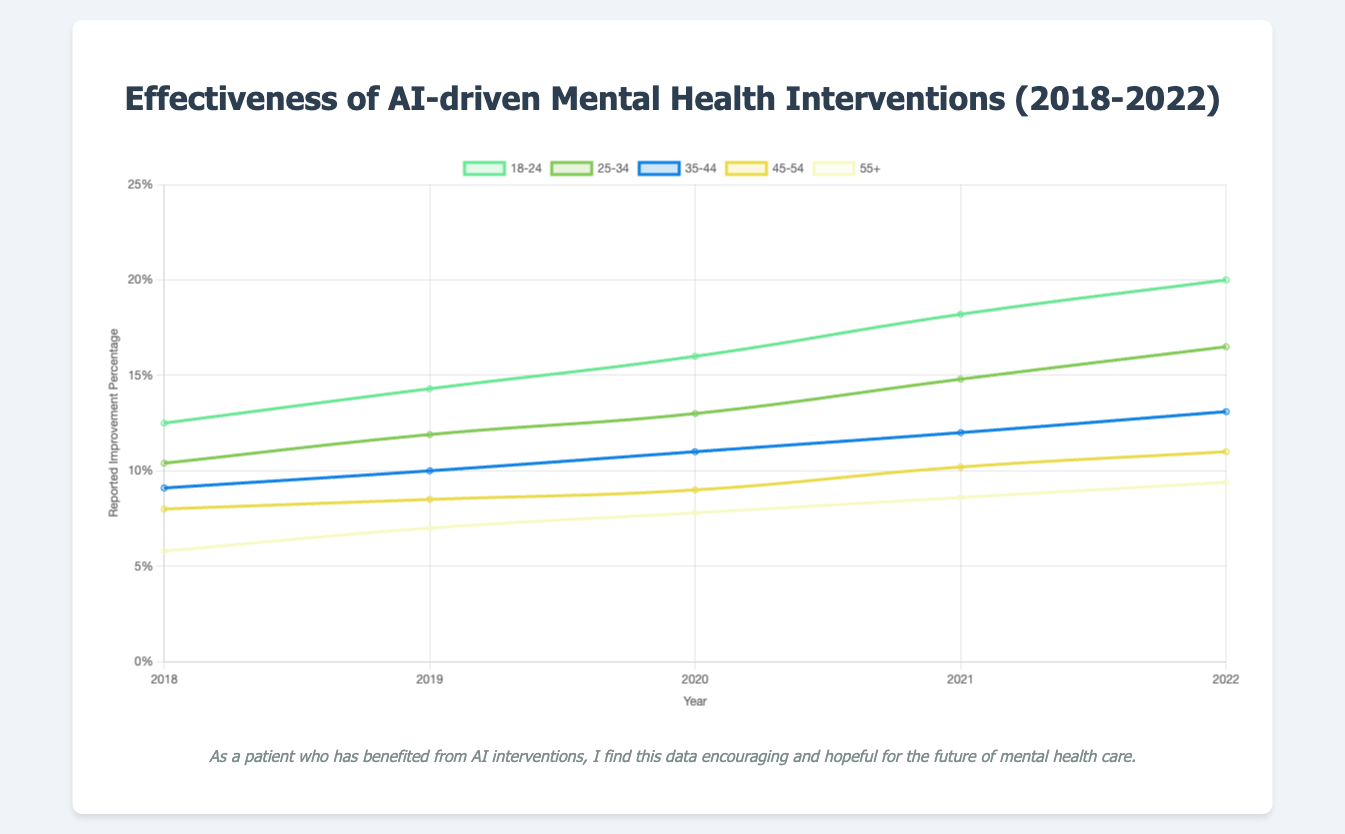What is the reported improvement percentage for the 18-24 age group in 2022? Locate the line corresponding to the 18-24 age group and find the data point for the year 2022. The reported improvement percentage for 2022 is 20.0%.
Answer: 20.0% Over which period did the 45-54 age group show the most significant improvement in reported improvement percentage? Calculate the difference in reported improvement percentage for the 45-54 age group for each subsequent year. 2018 to 2019: 8.5 - 8.0 = 0.5%, 2019 to 2020: 9.0 - 8.5 = 0.5%, 2020 to 2021: 10.2 - 9.0 = 1.2%, 2021 to 2022: 11.0 - 10.2 = 0.8%. The most significant improvement was from 2020 to 2021 with a 1.2% increase.
Answer: 2020 to 2021 Which two age groups show the closest reported improvement percentages in 2019? Compare the reported improvement percentages for all age groups in 2019. 18-24: 14.3%, 25-34: 11.9%, 35-44: 10.0%, 45-54: 8.5%, 55+: 7.0%. The age groups 35-44 and 45-54 have the closest values with a difference of 1.5%.
Answer: 35-44 and 45-54 What is the average improvement percentage for the 55+ age group from 2018 to 2022? Sum the reported improvement percentages for the 55+ age group from 2018 to 2022 and divide by the number of years: (5.8 + 7.0 + 7.8 + 8.6 + 9.4) / 5 = 38.6 / 5 = 7.72%.
Answer: 7.72% In 2020, which age group's line segment has the steepest slope? Calculate the slopes for 2019 to 2020 for each age group. 18-24: (16.0 - 14.3)/(2020 - 2019) = 1.7, 25-34: (13.0 - 11.9)/(2020 - 2019) = 1.1, 35-44: (11.0 - 10.0)/(2020 - 2019) = 1.0, 45-54: (9.0 - 8.5)/(2020 - 2019) = 0.5, 55+: (7.8 - 7.0)/(2020 - 2019) = 0.8. The age group 18-24 has the steepest slope with a difference of 1.7.
Answer: 18-24 Which year saw the greatest overall improvement in reported percentages across all age groups? Calculate the total improvement for each year by summing the differences for each age group from the previous year. 2018 to 2019: (14.3-12.5) + (11.9-10.4) + (10.0-9.1) + (8.5-8.0) + (7.0-5.8) = 1.8+1.5+0.9+0.5+1.2 = 5.9%, 2019 to 2020: (16.0-14.3) + (13.0-11.9) + (11.0-10.0) + (9.0-8.5) + (7.8-7.0) = 1.7+1.1+1.0+0.5+0.8 = 5.1%, 2020 to 2021: (18.2-16.0) + (14.8-13.0) + (12.0-11.0) + (10.2-9.0) + (8.6-7.8) = 2.2+1.8+1.0+1.2+0.8 = 7.0%, 2021 to 2022: (20.0-18.2) + (16.5-14.8) + (13.1-12.0) + (11.0-10.2) + (9.4-8.6) = 1.8+1.7+1.1+0.8+0.8 = 6.2%. The greatest improvement was from 2020 to 2021 with a total of 7.0%.
Answer: 2020 to 2021 